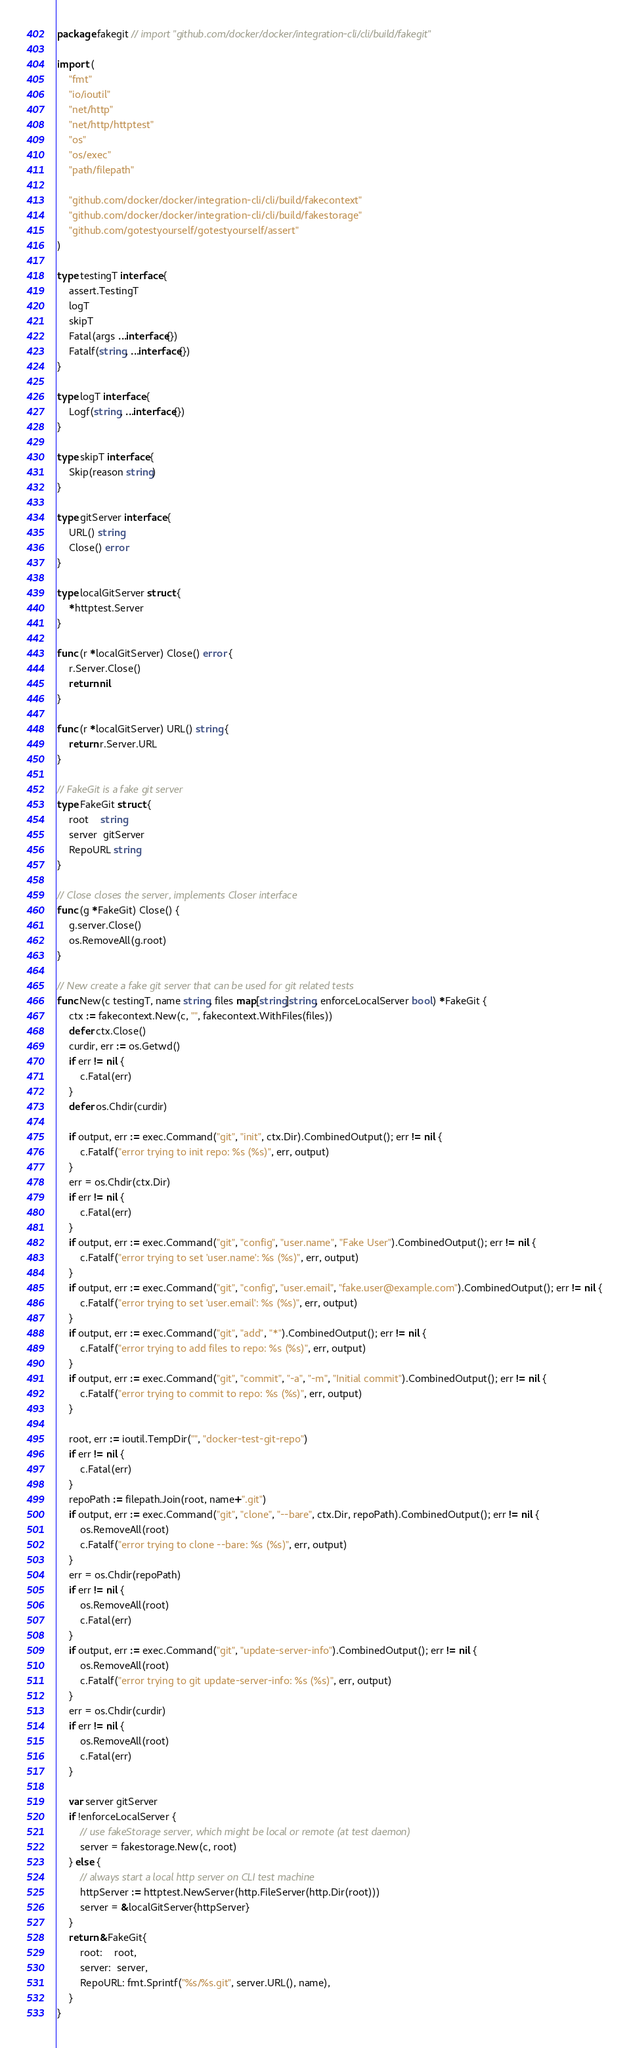<code> <loc_0><loc_0><loc_500><loc_500><_Go_>package fakegit // import "github.com/docker/docker/integration-cli/cli/build/fakegit"

import (
	"fmt"
	"io/ioutil"
	"net/http"
	"net/http/httptest"
	"os"
	"os/exec"
	"path/filepath"

	"github.com/docker/docker/integration-cli/cli/build/fakecontext"
	"github.com/docker/docker/integration-cli/cli/build/fakestorage"
	"github.com/gotestyourself/gotestyourself/assert"
)

type testingT interface {
	assert.TestingT
	logT
	skipT
	Fatal(args ...interface{})
	Fatalf(string, ...interface{})
}

type logT interface {
	Logf(string, ...interface{})
}

type skipT interface {
	Skip(reason string)
}

type gitServer interface {
	URL() string
	Close() error
}

type localGitServer struct {
	*httptest.Server
}

func (r *localGitServer) Close() error {
	r.Server.Close()
	return nil
}

func (r *localGitServer) URL() string {
	return r.Server.URL
}

// FakeGit is a fake git server
type FakeGit struct {
	root    string
	server  gitServer
	RepoURL string
}

// Close closes the server, implements Closer interface
func (g *FakeGit) Close() {
	g.server.Close()
	os.RemoveAll(g.root)
}

// New create a fake git server that can be used for git related tests
func New(c testingT, name string, files map[string]string, enforceLocalServer bool) *FakeGit {
	ctx := fakecontext.New(c, "", fakecontext.WithFiles(files))
	defer ctx.Close()
	curdir, err := os.Getwd()
	if err != nil {
		c.Fatal(err)
	}
	defer os.Chdir(curdir)

	if output, err := exec.Command("git", "init", ctx.Dir).CombinedOutput(); err != nil {
		c.Fatalf("error trying to init repo: %s (%s)", err, output)
	}
	err = os.Chdir(ctx.Dir)
	if err != nil {
		c.Fatal(err)
	}
	if output, err := exec.Command("git", "config", "user.name", "Fake User").CombinedOutput(); err != nil {
		c.Fatalf("error trying to set 'user.name': %s (%s)", err, output)
	}
	if output, err := exec.Command("git", "config", "user.email", "fake.user@example.com").CombinedOutput(); err != nil {
		c.Fatalf("error trying to set 'user.email': %s (%s)", err, output)
	}
	if output, err := exec.Command("git", "add", "*").CombinedOutput(); err != nil {
		c.Fatalf("error trying to add files to repo: %s (%s)", err, output)
	}
	if output, err := exec.Command("git", "commit", "-a", "-m", "Initial commit").CombinedOutput(); err != nil {
		c.Fatalf("error trying to commit to repo: %s (%s)", err, output)
	}

	root, err := ioutil.TempDir("", "docker-test-git-repo")
	if err != nil {
		c.Fatal(err)
	}
	repoPath := filepath.Join(root, name+".git")
	if output, err := exec.Command("git", "clone", "--bare", ctx.Dir, repoPath).CombinedOutput(); err != nil {
		os.RemoveAll(root)
		c.Fatalf("error trying to clone --bare: %s (%s)", err, output)
	}
	err = os.Chdir(repoPath)
	if err != nil {
		os.RemoveAll(root)
		c.Fatal(err)
	}
	if output, err := exec.Command("git", "update-server-info").CombinedOutput(); err != nil {
		os.RemoveAll(root)
		c.Fatalf("error trying to git update-server-info: %s (%s)", err, output)
	}
	err = os.Chdir(curdir)
	if err != nil {
		os.RemoveAll(root)
		c.Fatal(err)
	}

	var server gitServer
	if !enforceLocalServer {
		// use fakeStorage server, which might be local or remote (at test daemon)
		server = fakestorage.New(c, root)
	} else {
		// always start a local http server on CLI test machine
		httpServer := httptest.NewServer(http.FileServer(http.Dir(root)))
		server = &localGitServer{httpServer}
	}
	return &FakeGit{
		root:    root,
		server:  server,
		RepoURL: fmt.Sprintf("%s/%s.git", server.URL(), name),
	}
}
</code> 